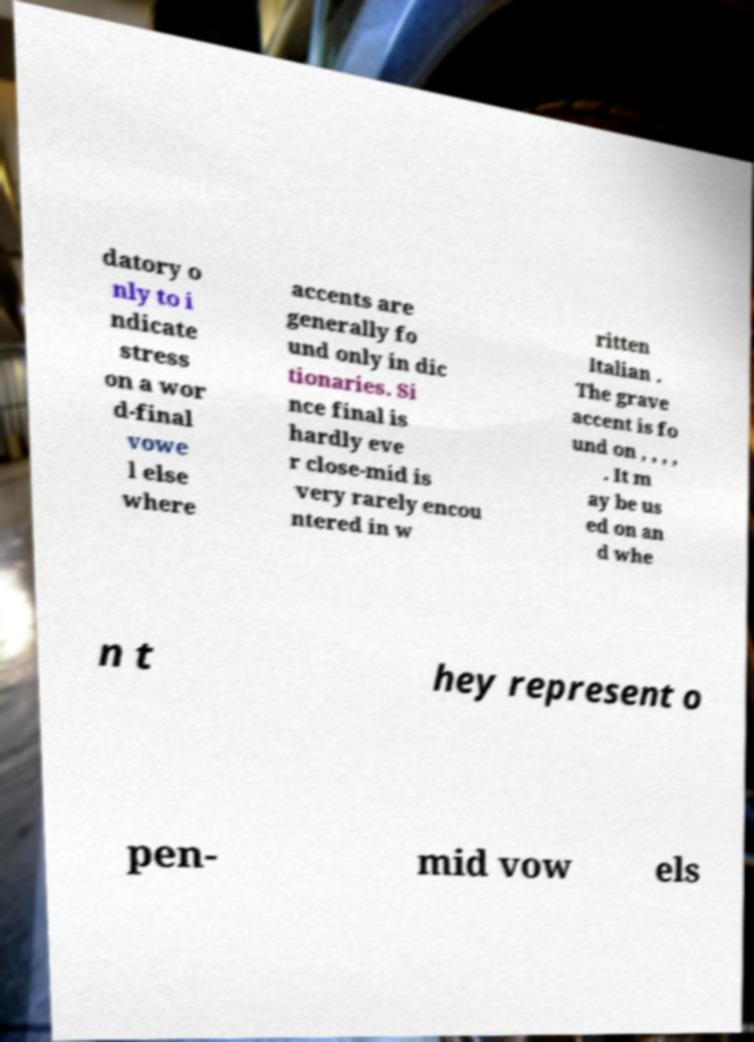There's text embedded in this image that I need extracted. Can you transcribe it verbatim? datory o nly to i ndicate stress on a wor d-final vowe l else where accents are generally fo und only in dic tionaries. Si nce final is hardly eve r close-mid is very rarely encou ntered in w ritten Italian . The grave accent is fo und on , , , , . It m ay be us ed on an d whe n t hey represent o pen- mid vow els 